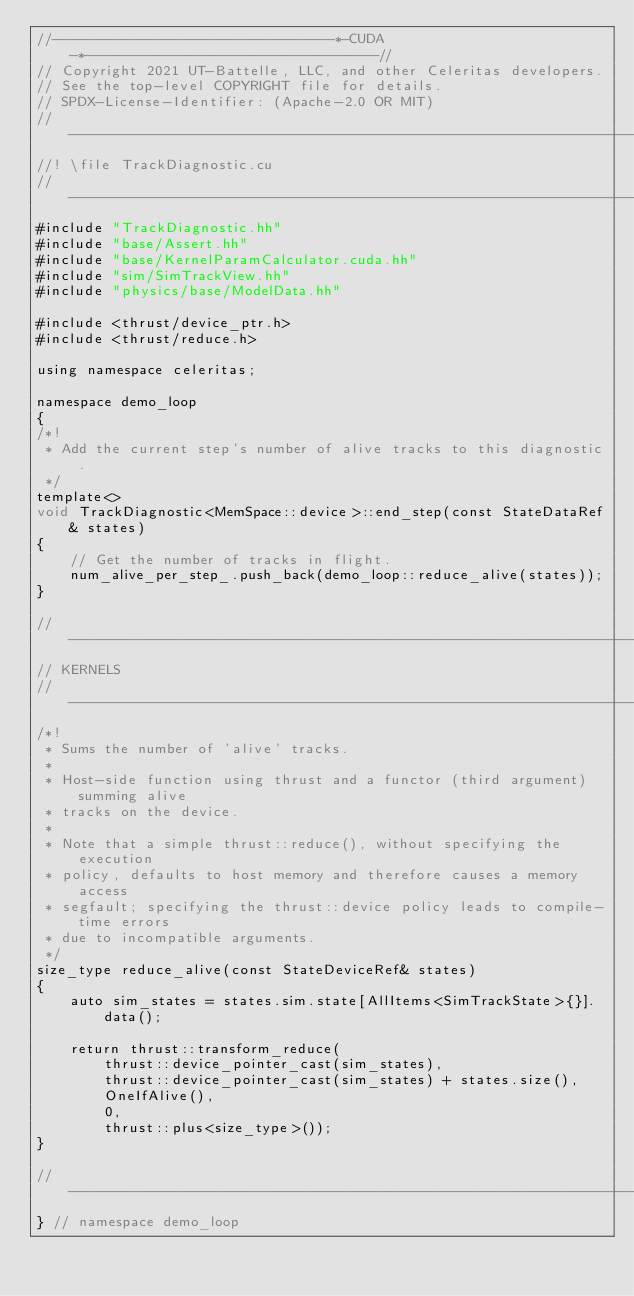<code> <loc_0><loc_0><loc_500><loc_500><_Cuda_>//---------------------------------*-CUDA-*----------------------------------//
// Copyright 2021 UT-Battelle, LLC, and other Celeritas developers.
// See the top-level COPYRIGHT file for details.
// SPDX-License-Identifier: (Apache-2.0 OR MIT)
//---------------------------------------------------------------------------//
//! \file TrackDiagnostic.cu
//---------------------------------------------------------------------------//
#include "TrackDiagnostic.hh"
#include "base/Assert.hh"
#include "base/KernelParamCalculator.cuda.hh"
#include "sim/SimTrackView.hh"
#include "physics/base/ModelData.hh"

#include <thrust/device_ptr.h>
#include <thrust/reduce.h>

using namespace celeritas;

namespace demo_loop
{
/*!
 * Add the current step's number of alive tracks to this diagnostic.
 */
template<>
void TrackDiagnostic<MemSpace::device>::end_step(const StateDataRef& states)
{
    // Get the number of tracks in flight.
    num_alive_per_step_.push_back(demo_loop::reduce_alive(states));
}

//---------------------------------------------------------------------------//
// KERNELS
//---------------------------------------------------------------------------//
/*!
 * Sums the number of 'alive' tracks.
 *
 * Host-side function using thrust and a functor (third argument) summing alive
 * tracks on the device.
 *
 * Note that a simple thrust::reduce(), without specifying the execution
 * policy, defaults to host memory and therefore causes a memory access
 * segfault; specifying the thrust::device policy leads to compile-time errors
 * due to incompatible arguments.
 */
size_type reduce_alive(const StateDeviceRef& states)
{
    auto sim_states = states.sim.state[AllItems<SimTrackState>{}].data();

    return thrust::transform_reduce(
        thrust::device_pointer_cast(sim_states),
        thrust::device_pointer_cast(sim_states) + states.size(),
        OneIfAlive(),
        0,
        thrust::plus<size_type>());
}

//---------------------------------------------------------------------------//
} // namespace demo_loop
</code> 